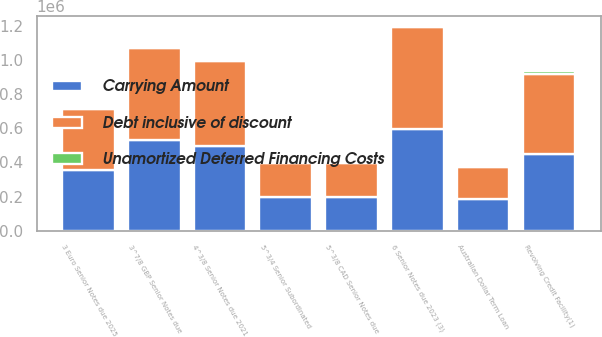<chart> <loc_0><loc_0><loc_500><loc_500><stacked_bar_chart><ecel><fcel>Revolving Credit Facility(1)<fcel>Australian Dollar Term Loan<fcel>4^3/8 Senior Notes due 2021<fcel>6 Senior Notes due 2023 (3)<fcel>5^3/8 CAD Senior Notes due<fcel>5^3/4 Senior Subordinated<fcel>3 Euro Senior Notes due 2025<fcel>3^7/8 GBP Senior Notes due<nl><fcel>Debt inclusive of discount<fcel>466593<fcel>187504<fcel>500000<fcel>600000<fcel>199171<fcel>197524<fcel>359386<fcel>539702<nl><fcel>Unamortized Deferred Financing Costs<fcel>14407<fcel>3382<fcel>5874<fcel>6224<fcel>3295<fcel>9156<fcel>4691<fcel>7718<nl><fcel>Carrying Amount<fcel>452186<fcel>184122<fcel>494126<fcel>593776<fcel>195876<fcel>197524<fcel>354695<fcel>531984<nl></chart> 